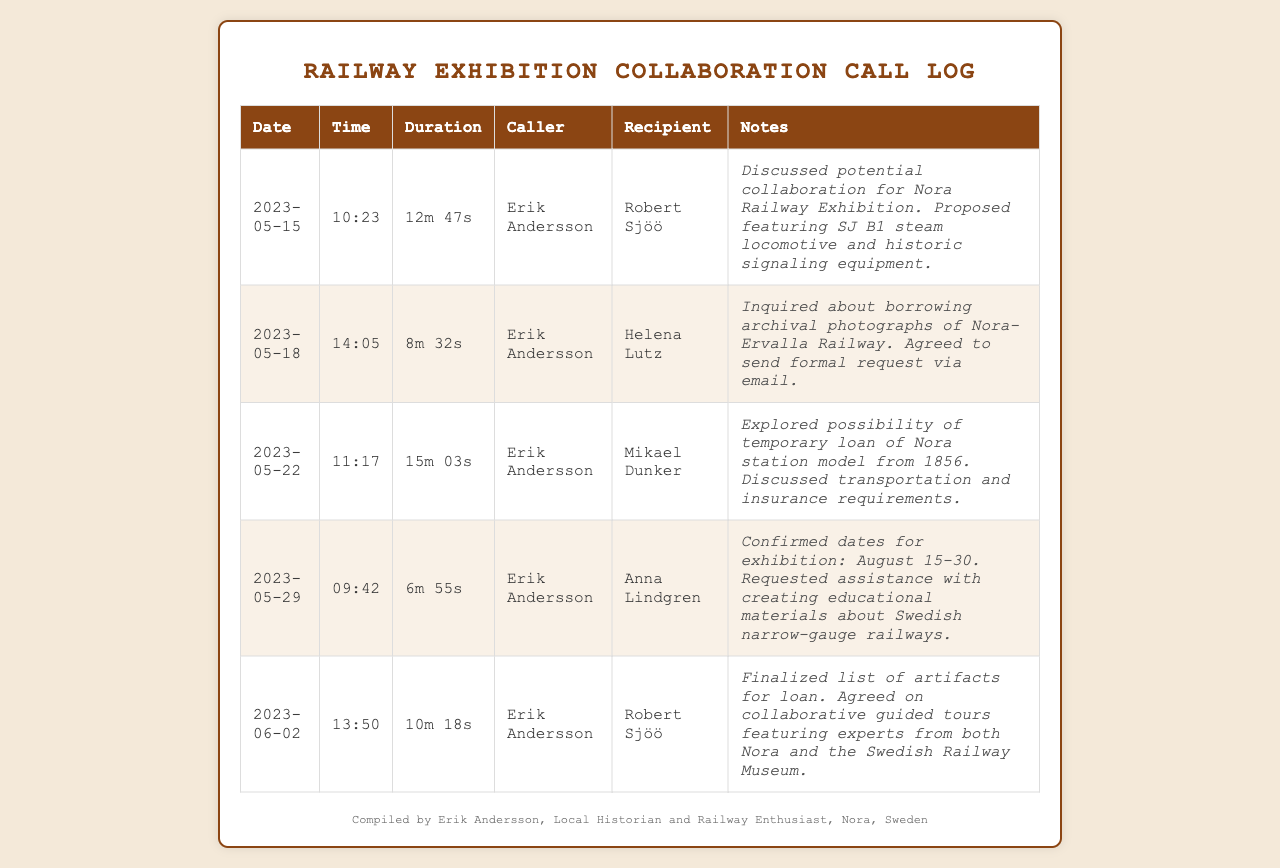what is the date of the first call? The first call was made on May 15, 2023, which is the earliest date listed in the log.
Answer: May 15, 2023 who was the caller during the second call? In the second call, Erik Andersson was the caller, as indicated in the call log.
Answer: Erik Andersson how long did the call with Helena Lutz last? The duration of the call with Helena Lutz is recorded as 8 minutes and 32 seconds.
Answer: 8m 32s what was discussed in the call on May 22? The call with Mikael Dunker on May 22 focused on the temporary loan of a Nora station model from 1856.
Answer: Temporary loan of Nora station model how many calls were made in May 2023? There are four calls listed that were made in May 2023, as indicated by the respective dates.
Answer: 4 what artifact was proposed to feature in the collaboration? The collaboration proposal included featuring the SJ B1 steam locomotive as part of the exhibition.
Answer: SJ B1 steam locomotive what dates were confirmed for the exhibition? The confirmed dates for the exhibition are August 15 to August 30.
Answer: August 15-30 who is responsible for compiling the call log? Erik Andersson, the local historian and railway enthusiast, compiled the call log.
Answer: Erik Andersson 